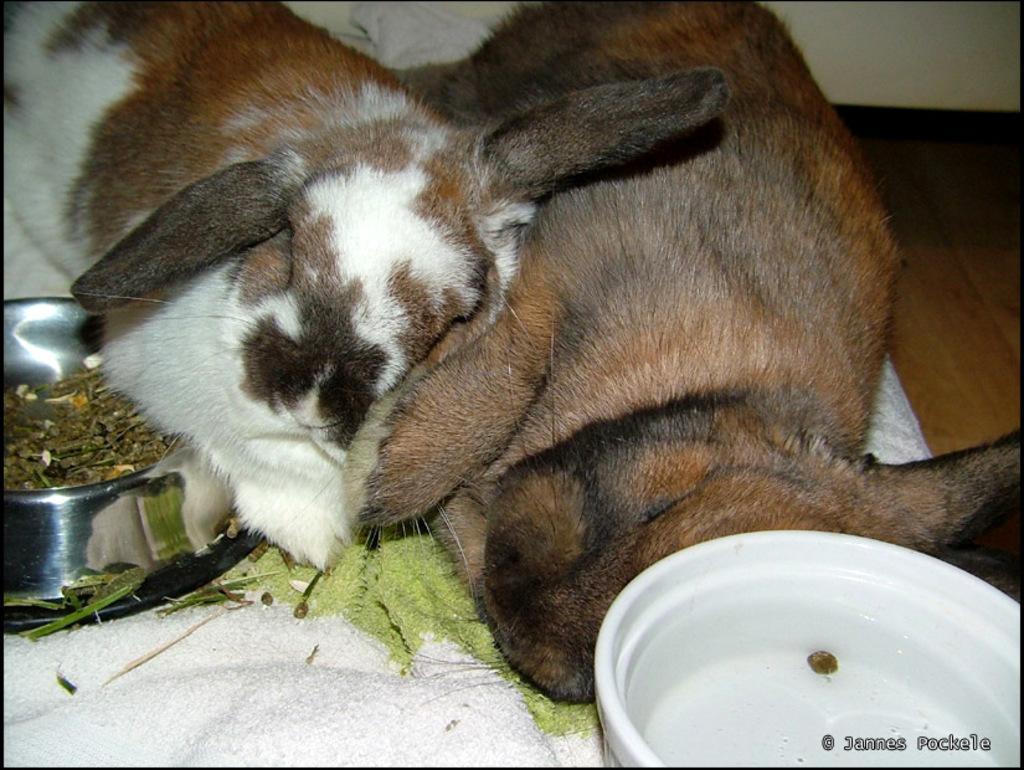Could you give a brief overview of what you see in this image? In this image there is a dog. There is a white color mat. There is a steel bowl on the left side. There is another bowl on the right side. There is a floor. There is a wall. 